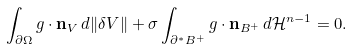Convert formula to latex. <formula><loc_0><loc_0><loc_500><loc_500>\int _ { \partial \Omega } g \cdot { \mathbf n } _ { V } \, d \| \delta V \| + \sigma \int _ { \partial ^ { * } B ^ { + } } g \cdot \mathbf n _ { B ^ { + } } \, d \mathcal { H } ^ { n - 1 } = 0 .</formula> 